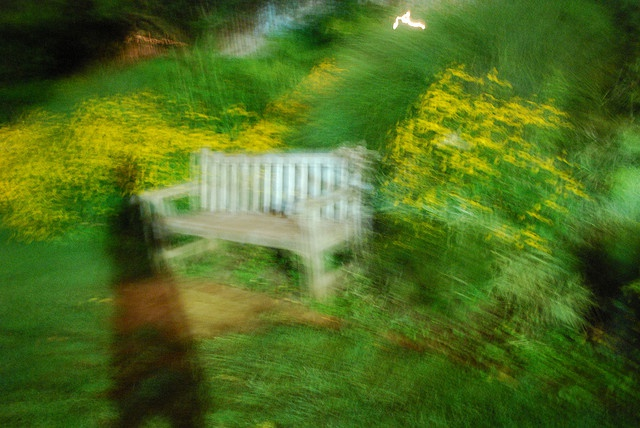Describe the objects in this image and their specific colors. I can see a bench in black, darkgray, beige, and olive tones in this image. 